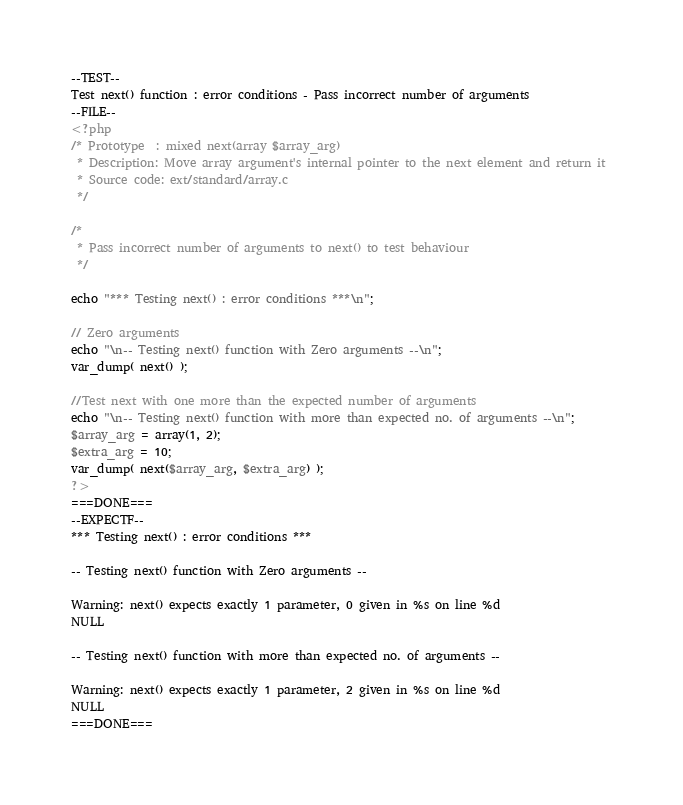<code> <loc_0><loc_0><loc_500><loc_500><_PHP_>--TEST--
Test next() function : error conditions - Pass incorrect number of arguments
--FILE--
<?php
/* Prototype  : mixed next(array $array_arg)
 * Description: Move array argument's internal pointer to the next element and return it 
 * Source code: ext/standard/array.c
 */

/*
 * Pass incorrect number of arguments to next() to test behaviour
 */

echo "*** Testing next() : error conditions ***\n";

// Zero arguments
echo "\n-- Testing next() function with Zero arguments --\n";
var_dump( next() );

//Test next with one more than the expected number of arguments
echo "\n-- Testing next() function with more than expected no. of arguments --\n";
$array_arg = array(1, 2);
$extra_arg = 10;
var_dump( next($array_arg, $extra_arg) );
?>
===DONE===
--EXPECTF--
*** Testing next() : error conditions ***

-- Testing next() function with Zero arguments --

Warning: next() expects exactly 1 parameter, 0 given in %s on line %d
NULL

-- Testing next() function with more than expected no. of arguments --

Warning: next() expects exactly 1 parameter, 2 given in %s on line %d
NULL
===DONE===
</code> 